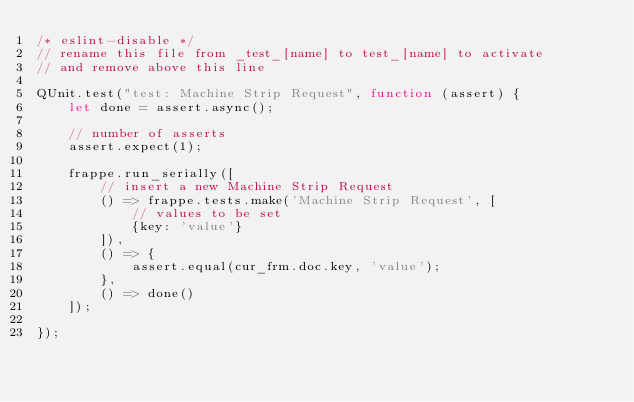<code> <loc_0><loc_0><loc_500><loc_500><_JavaScript_>/* eslint-disable */
// rename this file from _test_[name] to test_[name] to activate
// and remove above this line

QUnit.test("test: Machine Strip Request", function (assert) {
	let done = assert.async();

	// number of asserts
	assert.expect(1);

	frappe.run_serially([
		// insert a new Machine Strip Request
		() => frappe.tests.make('Machine Strip Request', [
			// values to be set
			{key: 'value'}
		]),
		() => {
			assert.equal(cur_frm.doc.key, 'value');
		},
		() => done()
	]);

});
</code> 